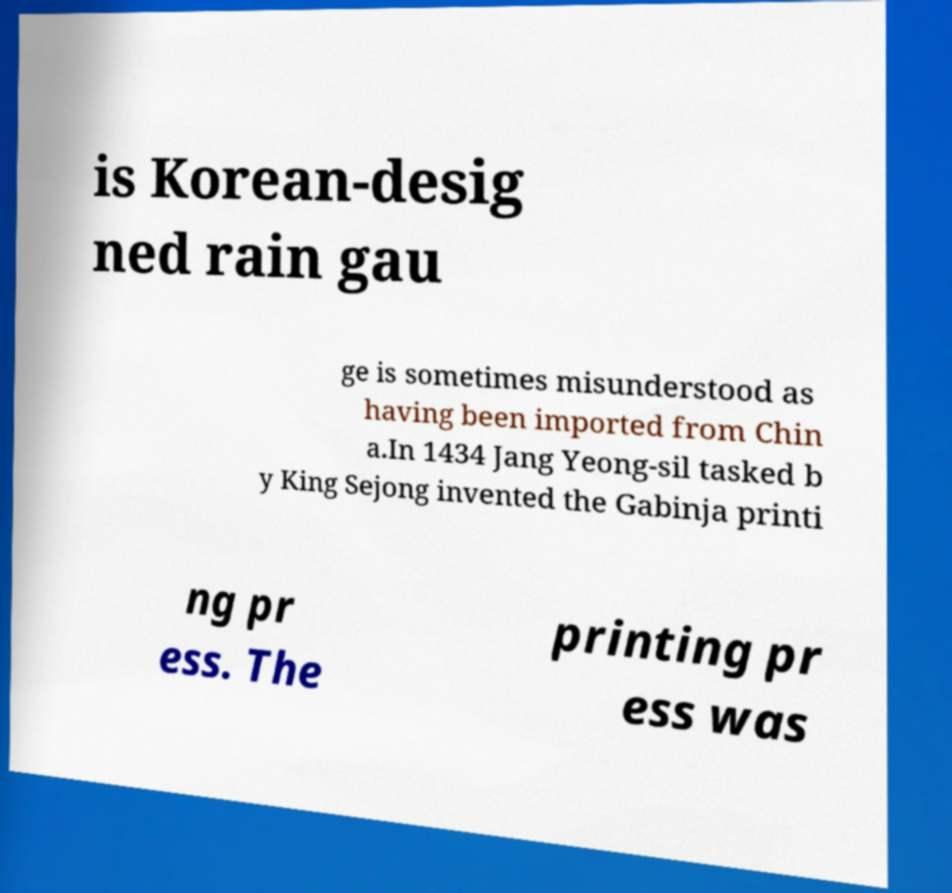Can you read and provide the text displayed in the image?This photo seems to have some interesting text. Can you extract and type it out for me? is Korean-desig ned rain gau ge is sometimes misunderstood as having been imported from Chin a.In 1434 Jang Yeong-sil tasked b y King Sejong invented the Gabinja printi ng pr ess. The printing pr ess was 